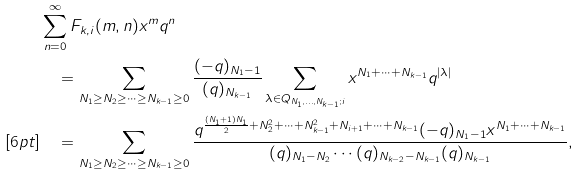<formula> <loc_0><loc_0><loc_500><loc_500>& \sum _ { n = 0 } ^ { \infty } F _ { k , i } ( m , n ) x ^ { m } q ^ { n } \\ & \quad = \sum _ { N _ { 1 } \geq N _ { 2 } \geq \cdots \geq N _ { k - 1 } \geq 0 } \frac { ( - q ) _ { N _ { 1 } - 1 } } { ( q ) _ { N _ { k - 1 } } } \sum _ { \lambda \in Q _ { N _ { 1 } , \dots , N _ { k - 1 } ; i } } x ^ { N _ { 1 } + \cdots + N _ { k - 1 } } q ^ { | \lambda | } \\ [ 6 p t ] & \quad = \sum _ { N _ { 1 } \geq N _ { 2 } \geq \cdots \geq N _ { k - 1 } \geq 0 } \frac { q ^ { \frac { ( N _ { 1 } + 1 ) N _ { 1 } } { 2 } + N _ { 2 } ^ { 2 } + \cdots + N _ { k - 1 } ^ { 2 } + N _ { i + 1 } + \cdots + N _ { k - 1 } } ( - q ) _ { N _ { 1 } - 1 } x ^ { N _ { 1 } + \cdots + N _ { k - 1 } } } { ( q ) _ { N _ { 1 } - N _ { 2 } } \cdots ( q ) _ { N _ { k - 2 } - N _ { k - 1 } } ( q ) _ { N _ { k - 1 } } } ,</formula> 